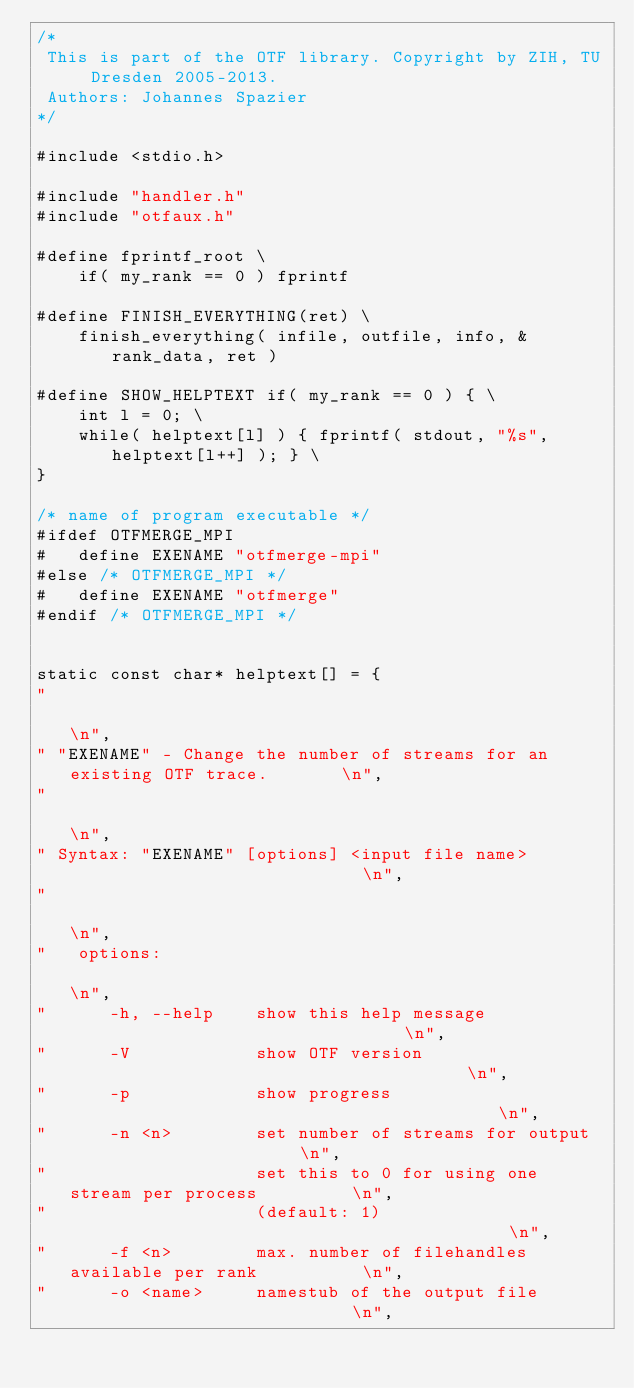Convert code to text. <code><loc_0><loc_0><loc_500><loc_500><_C_>/*
 This is part of the OTF library. Copyright by ZIH, TU Dresden 2005-2013.
 Authors: Johannes Spazier
*/

#include <stdio.h>

#include "handler.h"
#include "otfaux.h"

#define fprintf_root \
    if( my_rank == 0 ) fprintf

#define FINISH_EVERYTHING(ret) \
    finish_everything( infile, outfile, info, &rank_data, ret )

#define SHOW_HELPTEXT if( my_rank == 0 ) { \
    int l = 0; \
    while( helptext[l] ) { fprintf( stdout, "%s", helptext[l++] ); } \
}

/* name of program executable */
#ifdef OTFMERGE_MPI
#   define EXENAME "otfmerge-mpi"
#else /* OTFMERGE_MPI */
#   define EXENAME "otfmerge"
#endif /* OTFMERGE_MPI */


static const char* helptext[] = {
"                                                                           \n",
" "EXENAME" - Change the number of streams for an existing OTF trace.       \n",
"                                                                           \n",
" Syntax: "EXENAME" [options] <input file name>                             \n",
"                                                                           \n",
"   options:                                                                \n",
"      -h, --help    show this help message                                 \n",
"      -V            show OTF version                                       \n",
"      -p            show progress                                          \n",
"      -n <n>        set number of streams for output                       \n",
"                    set this to 0 for using one stream per process         \n",
"                    (default: 1)                                           \n",
"      -f <n>        max. number of filehandles available per rank          \n",
"      -o <name>     namestub of the output file                            \n",</code> 